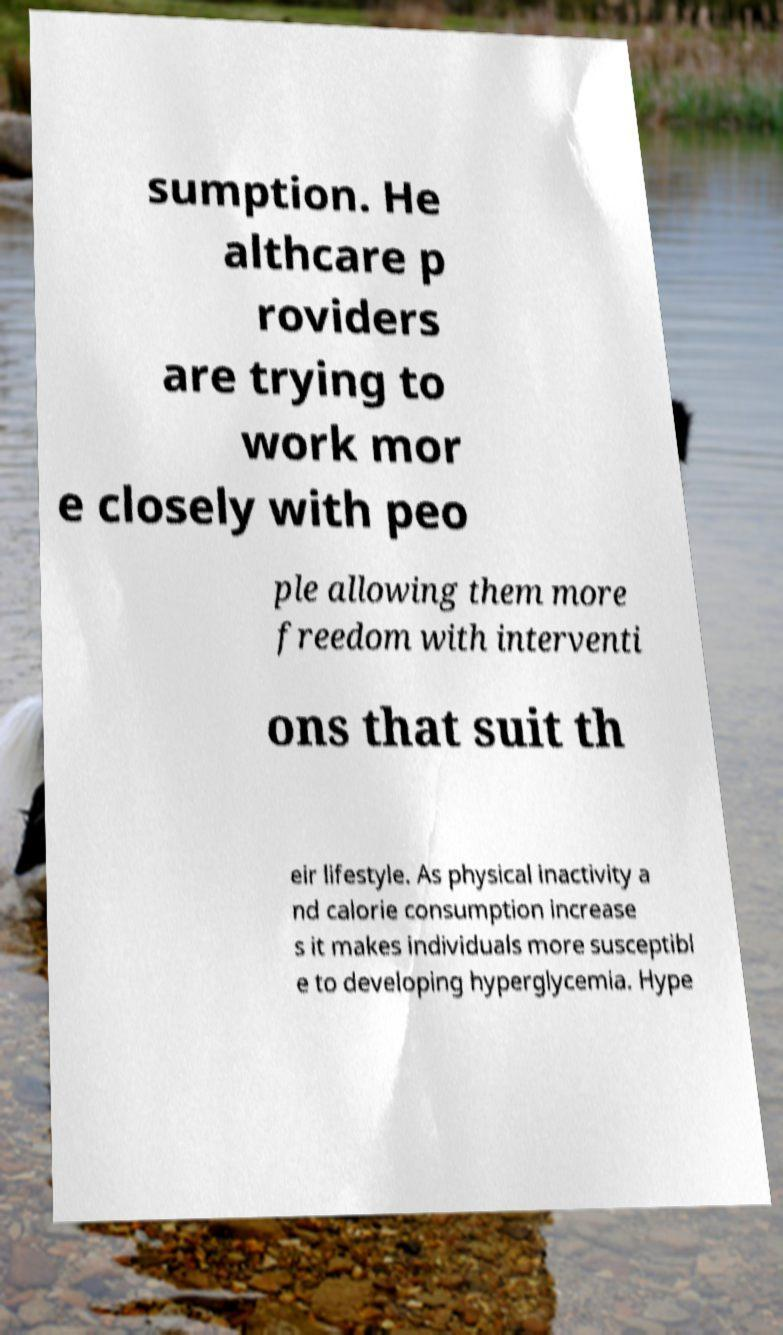What messages or text are displayed in this image? I need them in a readable, typed format. sumption. He althcare p roviders are trying to work mor e closely with peo ple allowing them more freedom with interventi ons that suit th eir lifestyle. As physical inactivity a nd calorie consumption increase s it makes individuals more susceptibl e to developing hyperglycemia. Hype 